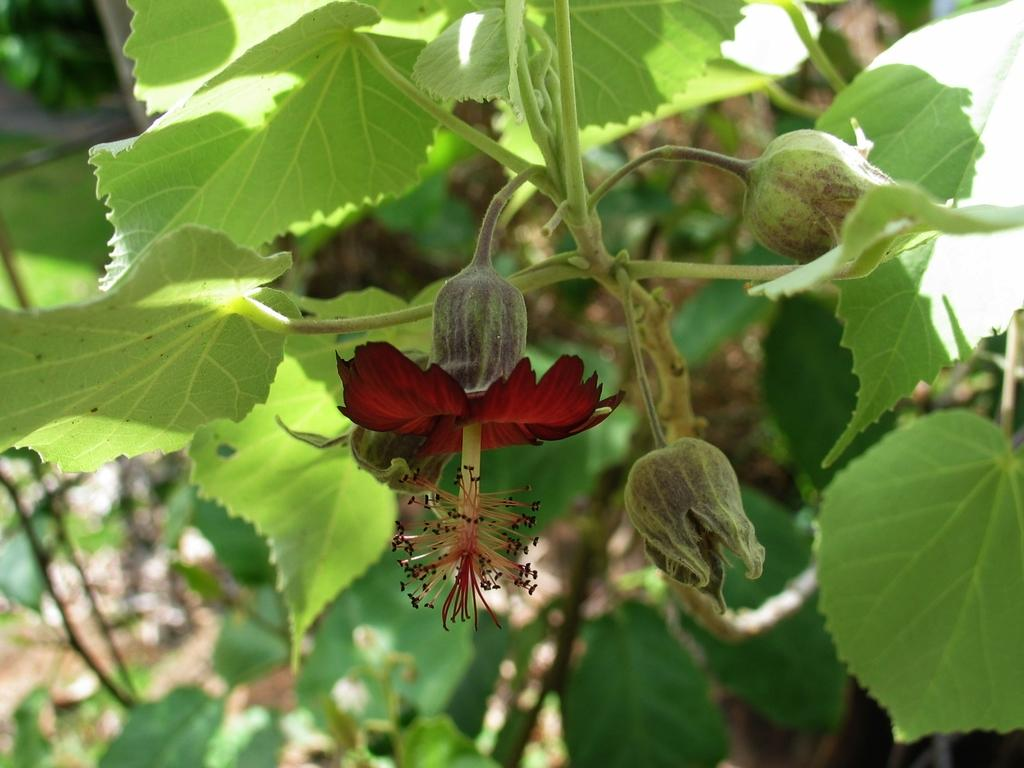What is the main subject in the middle of the image? There is a flower in the middle of the image. What is the stage of development for some of the flowers in the image? There are buds in the image. What type of living organisms are present in the image? There are plants in the image. What type of argument can be seen taking place between the chicken and the plate in the image? There is no chicken or plate present in the image; it features a flower and buds. 